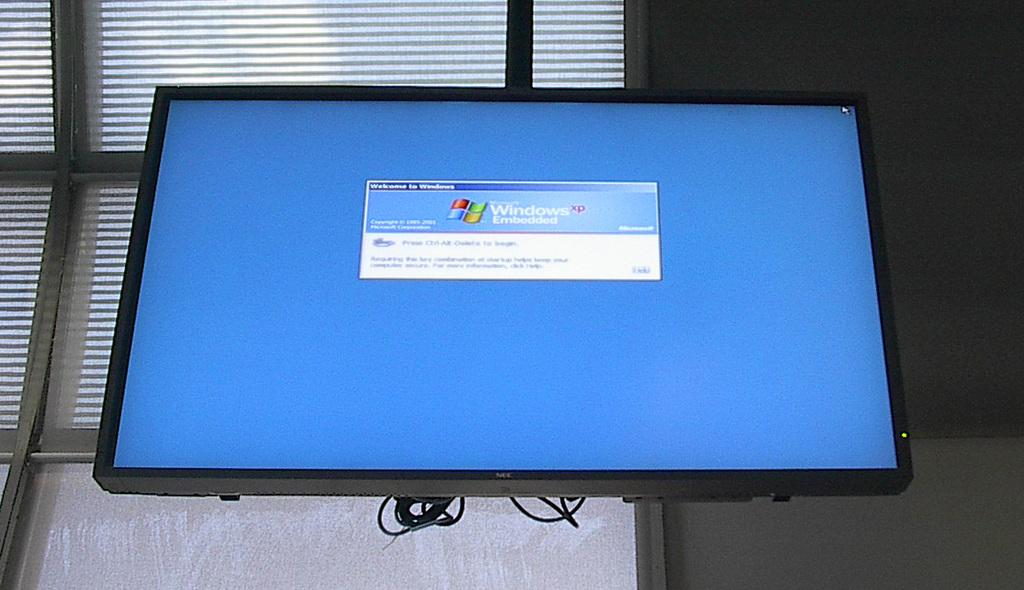<image>
Share a concise interpretation of the image provided. NEC television hanging and a screen that says "Window". 